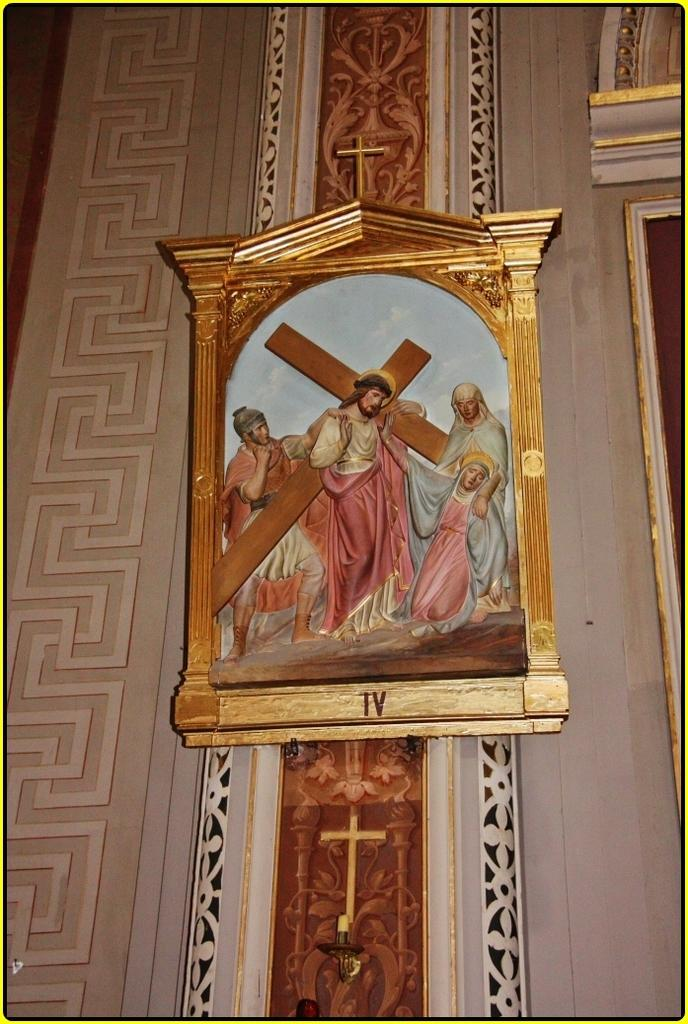<image>
Present a compact description of the photo's key features. The fourth station of the cross painted on a church wall 